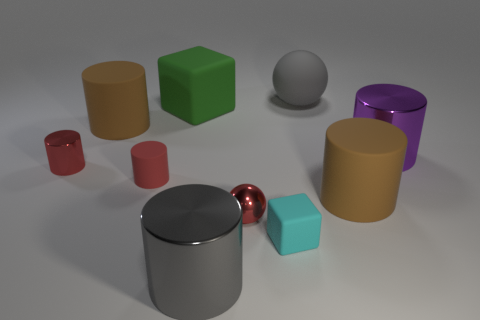Subtract all big brown matte cylinders. How many cylinders are left? 4 Subtract all purple cylinders. How many cylinders are left? 5 Subtract all purple cylinders. Subtract all red spheres. How many cylinders are left? 5 Subtract all cylinders. How many objects are left? 4 Add 7 red spheres. How many red spheres are left? 8 Add 3 big metal cylinders. How many big metal cylinders exist? 5 Subtract 0 cyan balls. How many objects are left? 10 Subtract all small blue rubber cylinders. Subtract all big brown rubber objects. How many objects are left? 8 